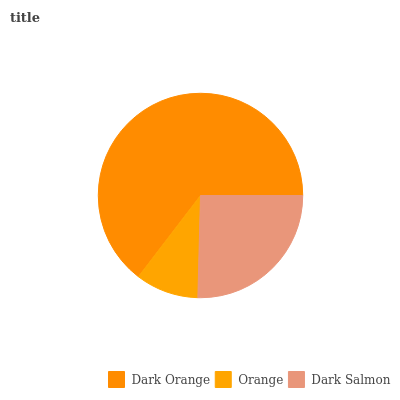Is Orange the minimum?
Answer yes or no. Yes. Is Dark Orange the maximum?
Answer yes or no. Yes. Is Dark Salmon the minimum?
Answer yes or no. No. Is Dark Salmon the maximum?
Answer yes or no. No. Is Dark Salmon greater than Orange?
Answer yes or no. Yes. Is Orange less than Dark Salmon?
Answer yes or no. Yes. Is Orange greater than Dark Salmon?
Answer yes or no. No. Is Dark Salmon less than Orange?
Answer yes or no. No. Is Dark Salmon the high median?
Answer yes or no. Yes. Is Dark Salmon the low median?
Answer yes or no. Yes. Is Orange the high median?
Answer yes or no. No. Is Dark Orange the low median?
Answer yes or no. No. 